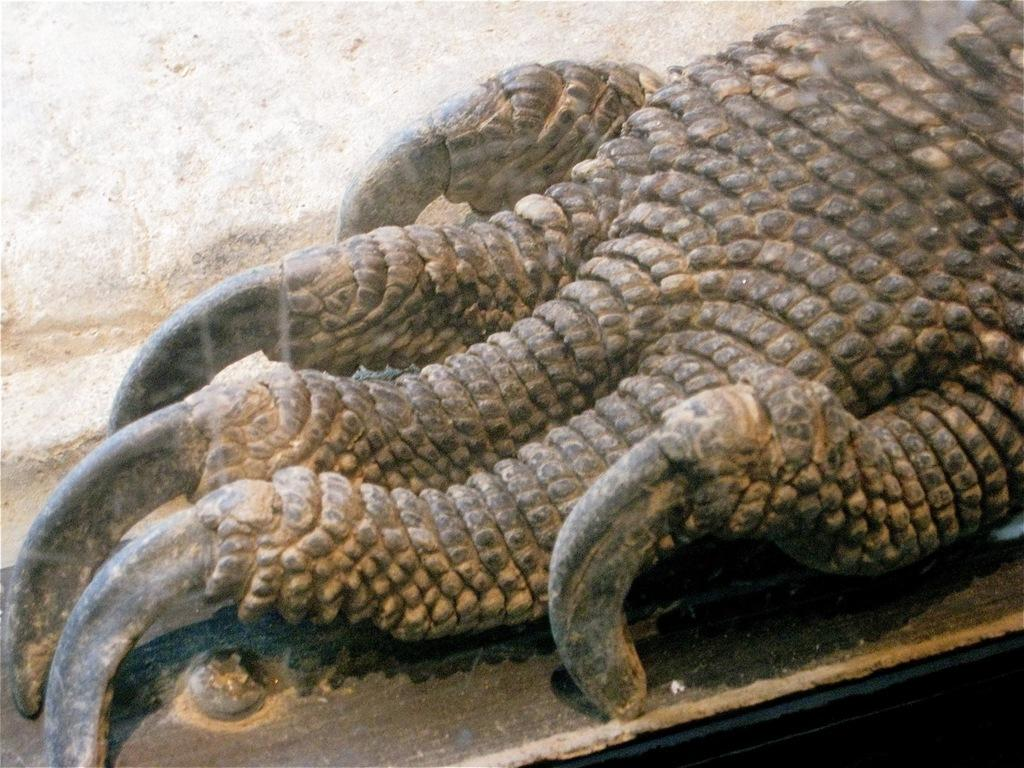What is the main subject of the image? The main subject of the image is a dragon paw. Can you describe the color of the dragon paw? The dragon paw is in black and brown color. What is the background of the image? There is a white wall in the image. How does the porter interact with the dragon paw in the image? There is no porter present in the image, so it is not possible to determine how a porter might interact with the dragon paw. 